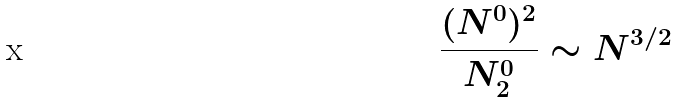<formula> <loc_0><loc_0><loc_500><loc_500>\frac { ( N ^ { 0 } ) ^ { 2 } } { N _ { 2 } ^ { 0 } } \sim N ^ { 3 / 2 }</formula> 